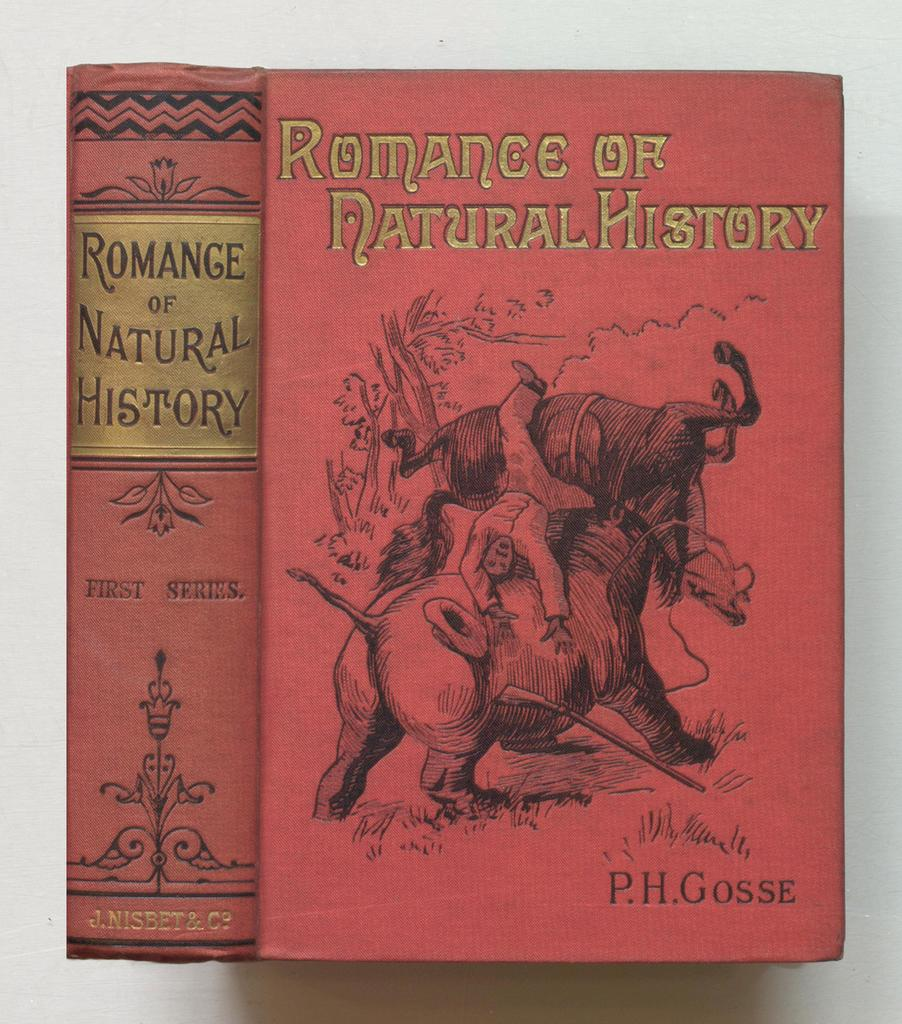<image>
Present a compact description of the photo's key features. Two books of Romance of Natural History by P.H. Gosse. 